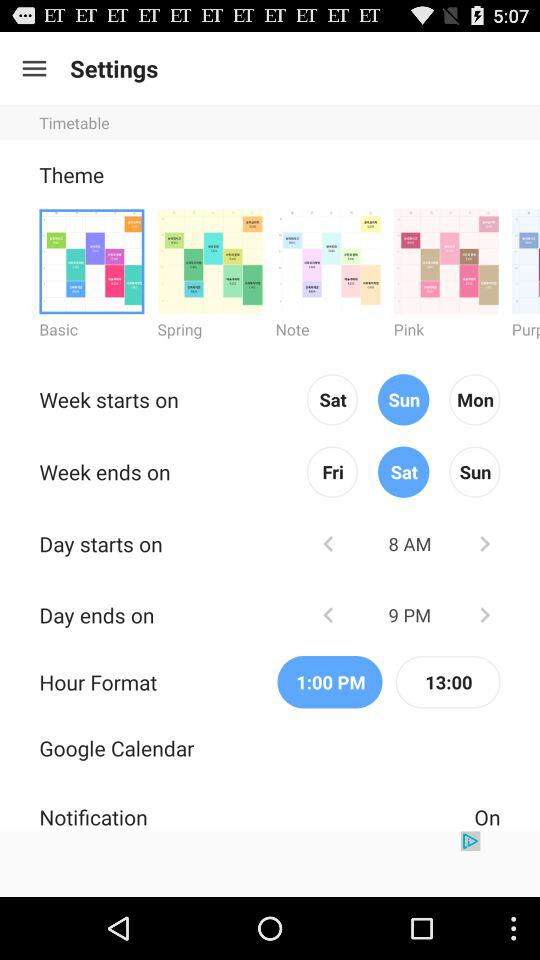Which theme is selected? The selected theme is Basic. 